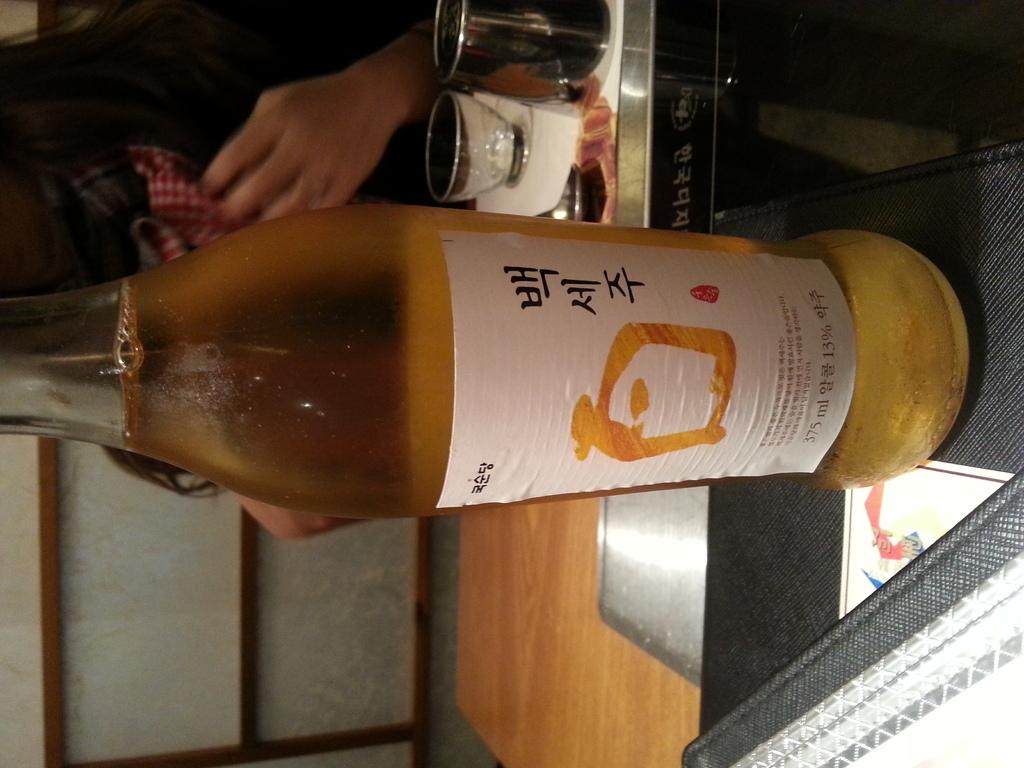What is on the table in the image? There is a beer bottle on the table. What else can be seen near the table? There are glasses on or near the table. What is the person near the table doing? There is a person sitting near the table. What other objects are around the person and table? There are other objects around the person and table. How much did the group pay for the beer in the image? There is no indication of a group or payment in the image; it only shows a beer bottle on the table and a person sitting near it. 